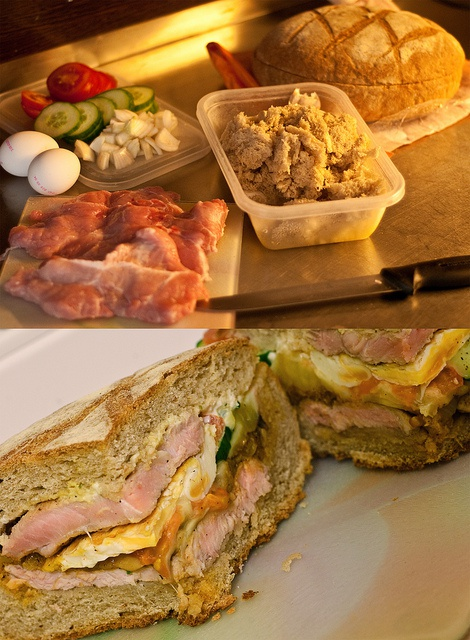Describe the objects in this image and their specific colors. I can see dining table in black, brown, maroon, and orange tones, sandwich in black, olive, and tan tones, sandwich in black, olive, and maroon tones, bowl in black, brown, orange, and maroon tones, and knife in black, maroon, and brown tones in this image. 